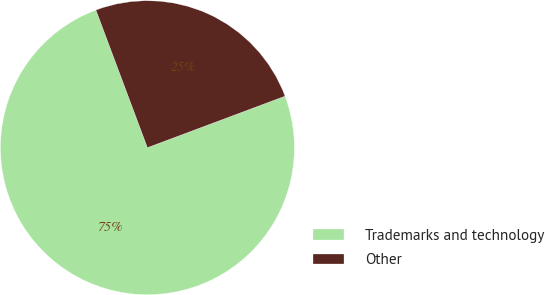Convert chart to OTSL. <chart><loc_0><loc_0><loc_500><loc_500><pie_chart><fcel>Trademarks and technology<fcel>Other<nl><fcel>75.0%<fcel>25.0%<nl></chart> 